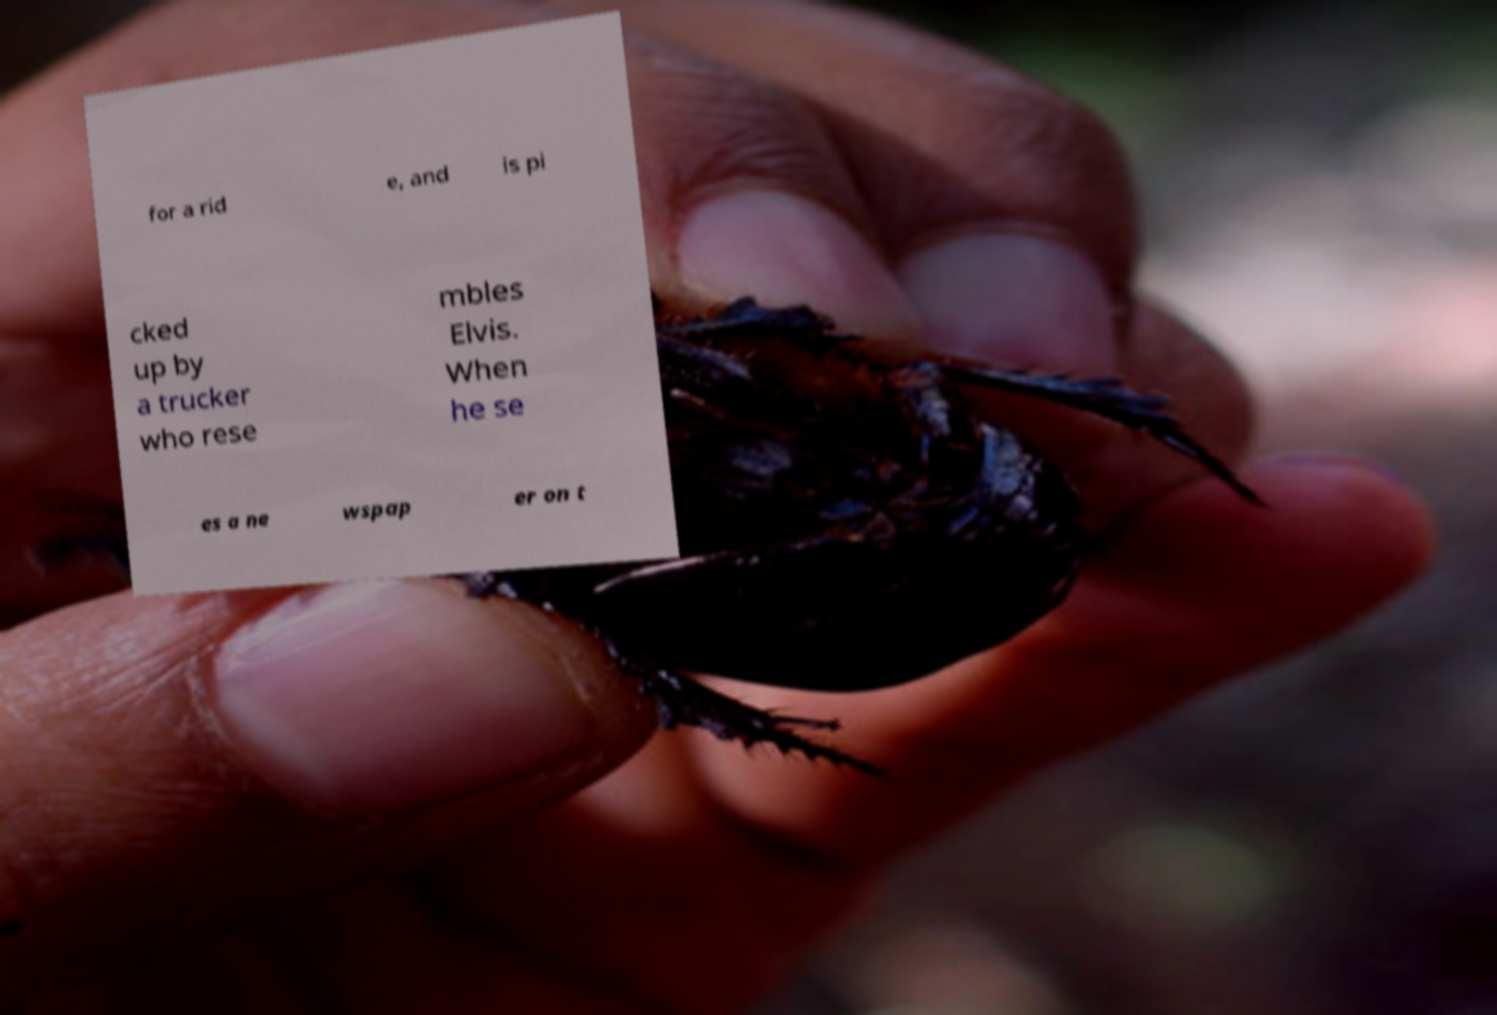Please identify and transcribe the text found in this image. for a rid e, and is pi cked up by a trucker who rese mbles Elvis. When he se es a ne wspap er on t 